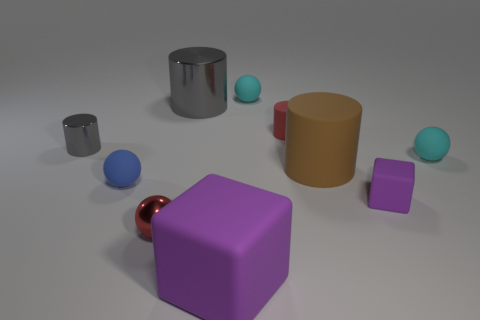There is a small shiny object that is behind the metallic sphere; what number of big gray cylinders are on the left side of it?
Provide a short and direct response. 0. What color is the tiny cylinder that is the same material as the tiny cube?
Provide a succinct answer. Red. Are there any brown rubber objects that have the same size as the metal sphere?
Provide a short and direct response. No. There is a blue thing that is the same size as the red cylinder; what shape is it?
Make the answer very short. Sphere. Is there a brown metal thing of the same shape as the small gray metallic thing?
Keep it short and to the point. No. Do the tiny block and the small red cylinder that is left of the small purple block have the same material?
Your answer should be compact. Yes. Is there a tiny thing that has the same color as the big cube?
Your answer should be very brief. Yes. How many other things are there of the same material as the red cylinder?
Your answer should be compact. 6. There is a big rubber block; is it the same color as the metal cylinder right of the blue object?
Your response must be concise. No. Is the number of objects right of the small red matte thing greater than the number of small blue things?
Give a very brief answer. Yes. 